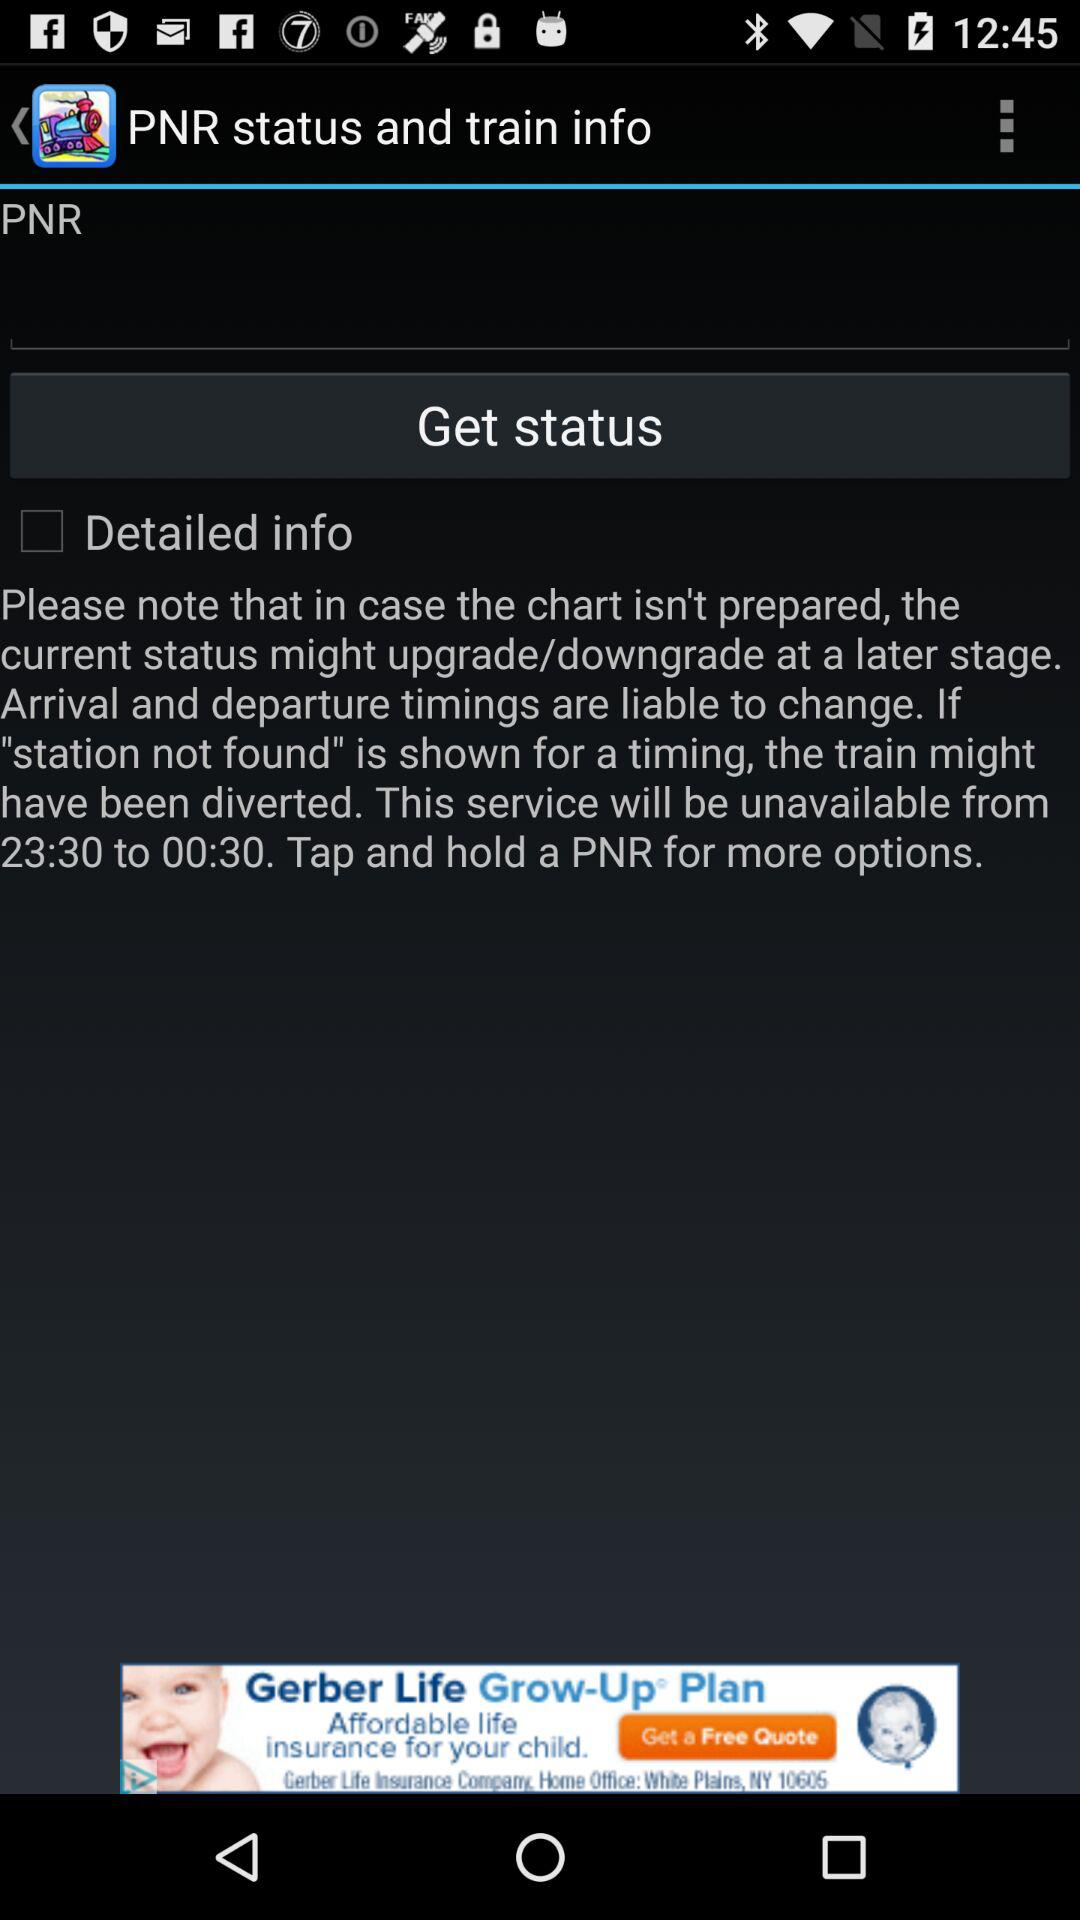At what time is the service unavailable? The service is unavailable from 23:30 to 00:30. 